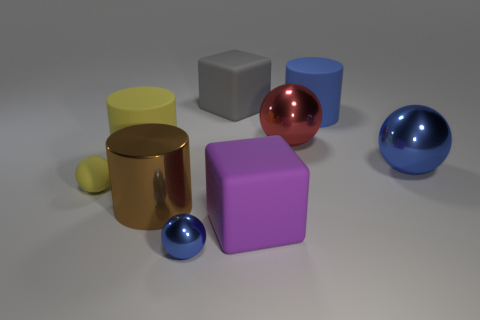The shiny thing that is the same color as the small metallic sphere is what shape? The shiny object sharing the same hue as the small metallic sphere is a larger sphere. 